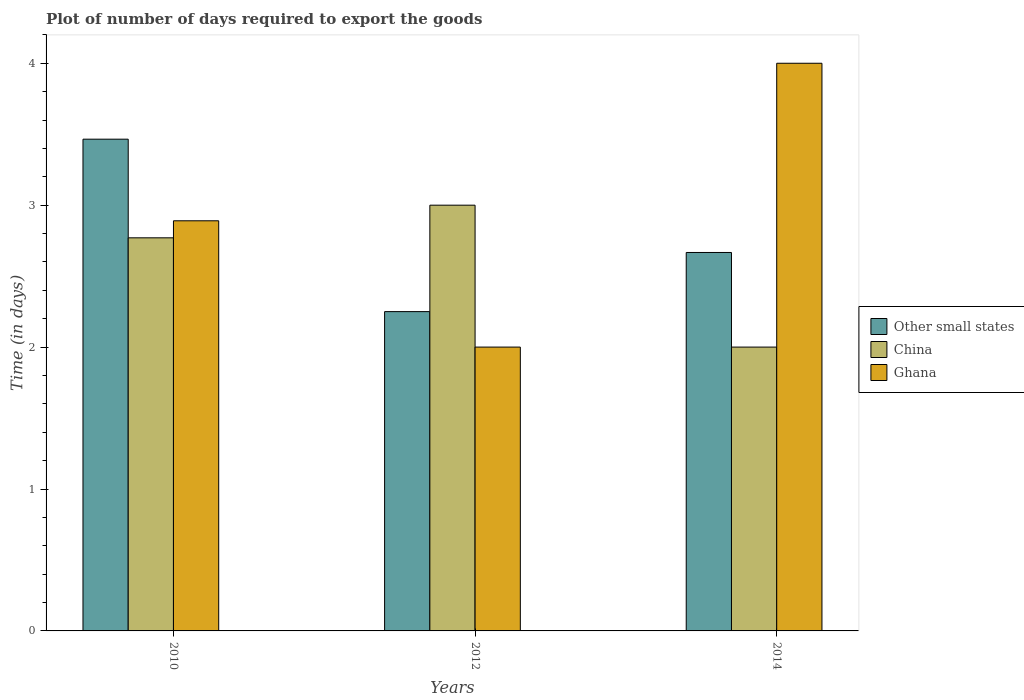How many different coloured bars are there?
Your response must be concise. 3. How many groups of bars are there?
Provide a succinct answer. 3. How many bars are there on the 2nd tick from the left?
Your answer should be very brief. 3. How many bars are there on the 2nd tick from the right?
Ensure brevity in your answer.  3. In how many cases, is the number of bars for a given year not equal to the number of legend labels?
Make the answer very short. 0. Across all years, what is the maximum time required to export goods in Ghana?
Provide a succinct answer. 4. Across all years, what is the minimum time required to export goods in Ghana?
Keep it short and to the point. 2. In which year was the time required to export goods in Ghana minimum?
Provide a short and direct response. 2012. What is the total time required to export goods in China in the graph?
Make the answer very short. 7.77. What is the difference between the time required to export goods in Other small states in 2010 and that in 2014?
Your response must be concise. 0.8. What is the difference between the time required to export goods in China in 2010 and the time required to export goods in Ghana in 2012?
Your response must be concise. 0.77. What is the average time required to export goods in Other small states per year?
Give a very brief answer. 2.79. What is the ratio of the time required to export goods in China in 2010 to that in 2014?
Ensure brevity in your answer.  1.39. Is the difference between the time required to export goods in China in 2012 and 2014 greater than the difference between the time required to export goods in Other small states in 2012 and 2014?
Offer a terse response. Yes. What is the difference between the highest and the second highest time required to export goods in Other small states?
Your response must be concise. 0.8. What is the difference between the highest and the lowest time required to export goods in Other small states?
Provide a short and direct response. 1.21. In how many years, is the time required to export goods in China greater than the average time required to export goods in China taken over all years?
Provide a succinct answer. 2. What does the 3rd bar from the right in 2010 represents?
Your answer should be very brief. Other small states. Is it the case that in every year, the sum of the time required to export goods in China and time required to export goods in Ghana is greater than the time required to export goods in Other small states?
Make the answer very short. Yes. How many bars are there?
Provide a short and direct response. 9. Are all the bars in the graph horizontal?
Your answer should be compact. No. How many years are there in the graph?
Make the answer very short. 3. What is the difference between two consecutive major ticks on the Y-axis?
Your answer should be compact. 1. Does the graph contain any zero values?
Provide a succinct answer. No. How many legend labels are there?
Keep it short and to the point. 3. What is the title of the graph?
Ensure brevity in your answer.  Plot of number of days required to export the goods. What is the label or title of the X-axis?
Make the answer very short. Years. What is the label or title of the Y-axis?
Offer a terse response. Time (in days). What is the Time (in days) in Other small states in 2010?
Provide a succinct answer. 3.46. What is the Time (in days) of China in 2010?
Give a very brief answer. 2.77. What is the Time (in days) in Ghana in 2010?
Keep it short and to the point. 2.89. What is the Time (in days) in Other small states in 2012?
Your answer should be very brief. 2.25. What is the Time (in days) of Ghana in 2012?
Your answer should be compact. 2. What is the Time (in days) in Other small states in 2014?
Offer a terse response. 2.67. What is the Time (in days) of China in 2014?
Make the answer very short. 2. What is the Time (in days) in Ghana in 2014?
Your answer should be compact. 4. Across all years, what is the maximum Time (in days) of Other small states?
Your answer should be compact. 3.46. Across all years, what is the maximum Time (in days) of China?
Offer a very short reply. 3. Across all years, what is the minimum Time (in days) in Other small states?
Provide a succinct answer. 2.25. Across all years, what is the minimum Time (in days) of Ghana?
Your answer should be very brief. 2. What is the total Time (in days) in Other small states in the graph?
Keep it short and to the point. 8.38. What is the total Time (in days) in China in the graph?
Make the answer very short. 7.77. What is the total Time (in days) of Ghana in the graph?
Your response must be concise. 8.89. What is the difference between the Time (in days) in Other small states in 2010 and that in 2012?
Provide a short and direct response. 1.22. What is the difference between the Time (in days) of China in 2010 and that in 2012?
Offer a terse response. -0.23. What is the difference between the Time (in days) in Ghana in 2010 and that in 2012?
Offer a very short reply. 0.89. What is the difference between the Time (in days) in Other small states in 2010 and that in 2014?
Give a very brief answer. 0.8. What is the difference between the Time (in days) in China in 2010 and that in 2014?
Ensure brevity in your answer.  0.77. What is the difference between the Time (in days) of Ghana in 2010 and that in 2014?
Keep it short and to the point. -1.11. What is the difference between the Time (in days) in Other small states in 2012 and that in 2014?
Keep it short and to the point. -0.42. What is the difference between the Time (in days) of Ghana in 2012 and that in 2014?
Your answer should be very brief. -2. What is the difference between the Time (in days) of Other small states in 2010 and the Time (in days) of China in 2012?
Ensure brevity in your answer.  0.47. What is the difference between the Time (in days) in Other small states in 2010 and the Time (in days) in Ghana in 2012?
Offer a very short reply. 1.47. What is the difference between the Time (in days) in China in 2010 and the Time (in days) in Ghana in 2012?
Offer a terse response. 0.77. What is the difference between the Time (in days) in Other small states in 2010 and the Time (in days) in China in 2014?
Keep it short and to the point. 1.47. What is the difference between the Time (in days) in Other small states in 2010 and the Time (in days) in Ghana in 2014?
Provide a succinct answer. -0.54. What is the difference between the Time (in days) of China in 2010 and the Time (in days) of Ghana in 2014?
Offer a very short reply. -1.23. What is the difference between the Time (in days) in Other small states in 2012 and the Time (in days) in China in 2014?
Your answer should be compact. 0.25. What is the difference between the Time (in days) of Other small states in 2012 and the Time (in days) of Ghana in 2014?
Provide a succinct answer. -1.75. What is the average Time (in days) of Other small states per year?
Your answer should be compact. 2.79. What is the average Time (in days) of China per year?
Provide a succinct answer. 2.59. What is the average Time (in days) of Ghana per year?
Give a very brief answer. 2.96. In the year 2010, what is the difference between the Time (in days) of Other small states and Time (in days) of China?
Make the answer very short. 0.69. In the year 2010, what is the difference between the Time (in days) in Other small states and Time (in days) in Ghana?
Ensure brevity in your answer.  0.57. In the year 2010, what is the difference between the Time (in days) of China and Time (in days) of Ghana?
Provide a succinct answer. -0.12. In the year 2012, what is the difference between the Time (in days) in Other small states and Time (in days) in China?
Your answer should be compact. -0.75. In the year 2012, what is the difference between the Time (in days) in Other small states and Time (in days) in Ghana?
Provide a succinct answer. 0.25. In the year 2012, what is the difference between the Time (in days) in China and Time (in days) in Ghana?
Offer a very short reply. 1. In the year 2014, what is the difference between the Time (in days) of Other small states and Time (in days) of China?
Provide a succinct answer. 0.67. In the year 2014, what is the difference between the Time (in days) in Other small states and Time (in days) in Ghana?
Your answer should be compact. -1.33. In the year 2014, what is the difference between the Time (in days) in China and Time (in days) in Ghana?
Make the answer very short. -2. What is the ratio of the Time (in days) in Other small states in 2010 to that in 2012?
Your answer should be compact. 1.54. What is the ratio of the Time (in days) of China in 2010 to that in 2012?
Your answer should be compact. 0.92. What is the ratio of the Time (in days) of Ghana in 2010 to that in 2012?
Keep it short and to the point. 1.45. What is the ratio of the Time (in days) in Other small states in 2010 to that in 2014?
Provide a succinct answer. 1.3. What is the ratio of the Time (in days) of China in 2010 to that in 2014?
Ensure brevity in your answer.  1.39. What is the ratio of the Time (in days) in Ghana in 2010 to that in 2014?
Provide a short and direct response. 0.72. What is the ratio of the Time (in days) of Other small states in 2012 to that in 2014?
Ensure brevity in your answer.  0.84. What is the ratio of the Time (in days) in China in 2012 to that in 2014?
Provide a succinct answer. 1.5. What is the ratio of the Time (in days) of Ghana in 2012 to that in 2014?
Your response must be concise. 0.5. What is the difference between the highest and the second highest Time (in days) of Other small states?
Offer a terse response. 0.8. What is the difference between the highest and the second highest Time (in days) in China?
Offer a very short reply. 0.23. What is the difference between the highest and the second highest Time (in days) in Ghana?
Provide a succinct answer. 1.11. What is the difference between the highest and the lowest Time (in days) of Other small states?
Make the answer very short. 1.22. What is the difference between the highest and the lowest Time (in days) in China?
Offer a terse response. 1. What is the difference between the highest and the lowest Time (in days) of Ghana?
Your answer should be very brief. 2. 